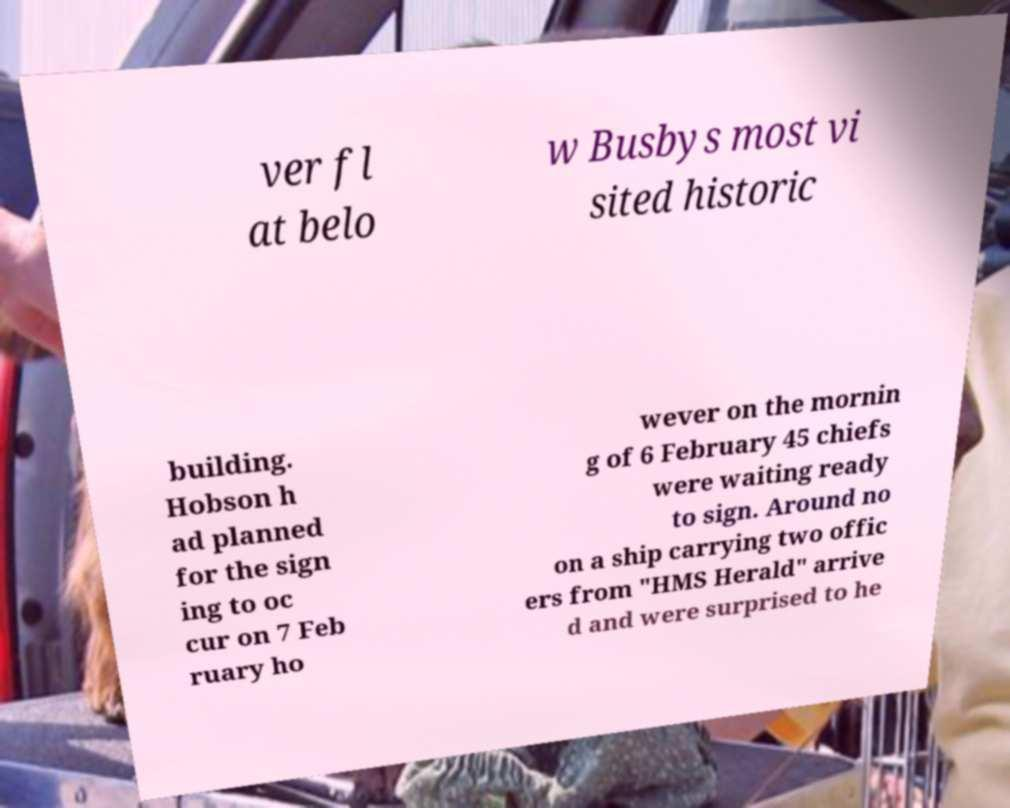Can you accurately transcribe the text from the provided image for me? ver fl at belo w Busbys most vi sited historic building. Hobson h ad planned for the sign ing to oc cur on 7 Feb ruary ho wever on the mornin g of 6 February 45 chiefs were waiting ready to sign. Around no on a ship carrying two offic ers from "HMS Herald" arrive d and were surprised to he 